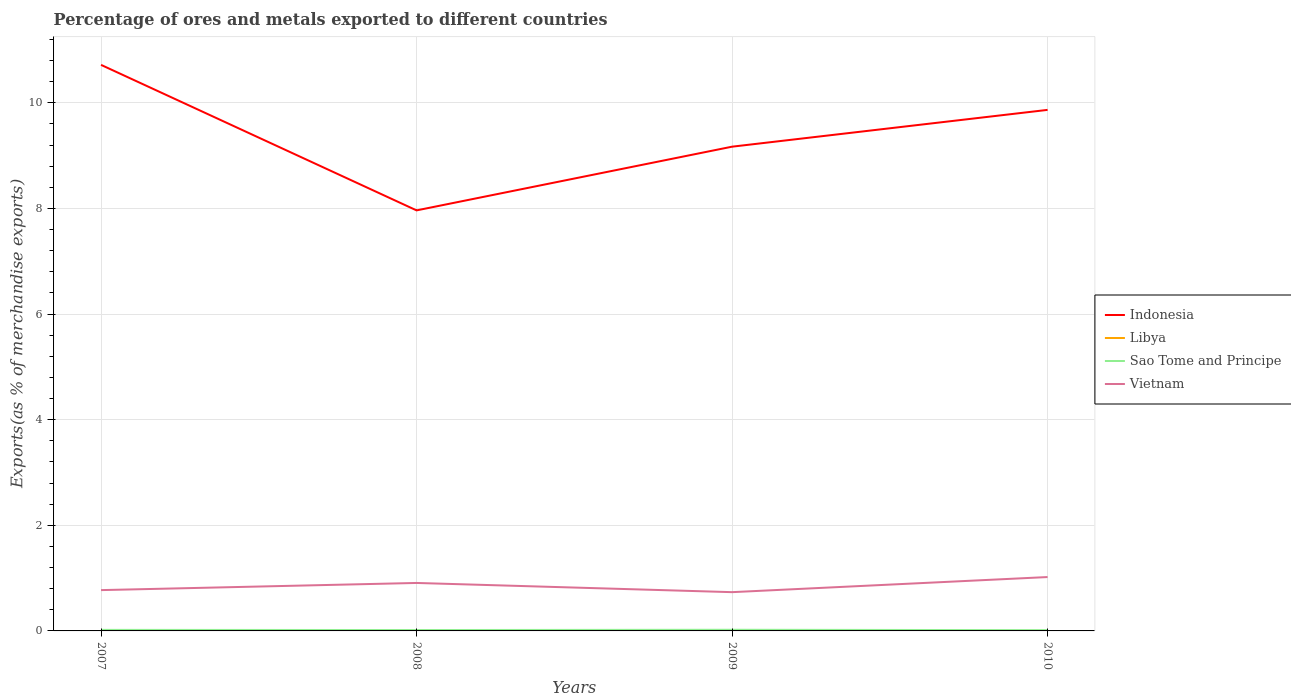How many different coloured lines are there?
Your response must be concise. 4. Is the number of lines equal to the number of legend labels?
Give a very brief answer. Yes. Across all years, what is the maximum percentage of exports to different countries in Libya?
Keep it short and to the point. 0. What is the total percentage of exports to different countries in Sao Tome and Principe in the graph?
Your answer should be compact. 0. What is the difference between the highest and the second highest percentage of exports to different countries in Sao Tome and Principe?
Your response must be concise. 0.01. Is the percentage of exports to different countries in Libya strictly greater than the percentage of exports to different countries in Vietnam over the years?
Provide a short and direct response. Yes. How many lines are there?
Give a very brief answer. 4. How many years are there in the graph?
Give a very brief answer. 4. What is the difference between two consecutive major ticks on the Y-axis?
Your answer should be very brief. 2. Are the values on the major ticks of Y-axis written in scientific E-notation?
Your answer should be compact. No. Does the graph contain grids?
Your answer should be very brief. Yes. How many legend labels are there?
Offer a very short reply. 4. What is the title of the graph?
Make the answer very short. Percentage of ores and metals exported to different countries. What is the label or title of the X-axis?
Provide a short and direct response. Years. What is the label or title of the Y-axis?
Give a very brief answer. Exports(as % of merchandise exports). What is the Exports(as % of merchandise exports) in Indonesia in 2007?
Offer a very short reply. 10.72. What is the Exports(as % of merchandise exports) of Libya in 2007?
Your response must be concise. 0.01. What is the Exports(as % of merchandise exports) in Sao Tome and Principe in 2007?
Your answer should be very brief. 0.02. What is the Exports(as % of merchandise exports) in Vietnam in 2007?
Keep it short and to the point. 0.77. What is the Exports(as % of merchandise exports) of Indonesia in 2008?
Give a very brief answer. 7.96. What is the Exports(as % of merchandise exports) in Libya in 2008?
Give a very brief answer. 0.01. What is the Exports(as % of merchandise exports) of Sao Tome and Principe in 2008?
Ensure brevity in your answer.  0.02. What is the Exports(as % of merchandise exports) in Vietnam in 2008?
Keep it short and to the point. 0.91. What is the Exports(as % of merchandise exports) in Indonesia in 2009?
Provide a short and direct response. 9.17. What is the Exports(as % of merchandise exports) in Libya in 2009?
Your response must be concise. 0. What is the Exports(as % of merchandise exports) in Sao Tome and Principe in 2009?
Provide a short and direct response. 0.02. What is the Exports(as % of merchandise exports) of Vietnam in 2009?
Your answer should be very brief. 0.73. What is the Exports(as % of merchandise exports) of Indonesia in 2010?
Give a very brief answer. 9.87. What is the Exports(as % of merchandise exports) in Libya in 2010?
Give a very brief answer. 0. What is the Exports(as % of merchandise exports) in Sao Tome and Principe in 2010?
Provide a short and direct response. 0.01. What is the Exports(as % of merchandise exports) in Vietnam in 2010?
Offer a very short reply. 1.02. Across all years, what is the maximum Exports(as % of merchandise exports) in Indonesia?
Your answer should be very brief. 10.72. Across all years, what is the maximum Exports(as % of merchandise exports) in Libya?
Give a very brief answer. 0.01. Across all years, what is the maximum Exports(as % of merchandise exports) in Sao Tome and Principe?
Provide a succinct answer. 0.02. Across all years, what is the maximum Exports(as % of merchandise exports) of Vietnam?
Your answer should be very brief. 1.02. Across all years, what is the minimum Exports(as % of merchandise exports) in Indonesia?
Provide a succinct answer. 7.96. Across all years, what is the minimum Exports(as % of merchandise exports) in Libya?
Ensure brevity in your answer.  0. Across all years, what is the minimum Exports(as % of merchandise exports) of Sao Tome and Principe?
Your answer should be compact. 0.01. Across all years, what is the minimum Exports(as % of merchandise exports) in Vietnam?
Your answer should be compact. 0.73. What is the total Exports(as % of merchandise exports) of Indonesia in the graph?
Provide a short and direct response. 37.72. What is the total Exports(as % of merchandise exports) of Libya in the graph?
Give a very brief answer. 0.01. What is the total Exports(as % of merchandise exports) in Sao Tome and Principe in the graph?
Your answer should be very brief. 0.07. What is the total Exports(as % of merchandise exports) in Vietnam in the graph?
Your answer should be compact. 3.44. What is the difference between the Exports(as % of merchandise exports) in Indonesia in 2007 and that in 2008?
Give a very brief answer. 2.76. What is the difference between the Exports(as % of merchandise exports) of Libya in 2007 and that in 2008?
Provide a short and direct response. 0. What is the difference between the Exports(as % of merchandise exports) in Sao Tome and Principe in 2007 and that in 2008?
Ensure brevity in your answer.  0. What is the difference between the Exports(as % of merchandise exports) of Vietnam in 2007 and that in 2008?
Provide a succinct answer. -0.14. What is the difference between the Exports(as % of merchandise exports) of Indonesia in 2007 and that in 2009?
Offer a terse response. 1.55. What is the difference between the Exports(as % of merchandise exports) of Libya in 2007 and that in 2009?
Keep it short and to the point. 0.01. What is the difference between the Exports(as % of merchandise exports) in Sao Tome and Principe in 2007 and that in 2009?
Provide a short and direct response. -0. What is the difference between the Exports(as % of merchandise exports) of Vietnam in 2007 and that in 2009?
Give a very brief answer. 0.04. What is the difference between the Exports(as % of merchandise exports) of Indonesia in 2007 and that in 2010?
Ensure brevity in your answer.  0.85. What is the difference between the Exports(as % of merchandise exports) of Libya in 2007 and that in 2010?
Offer a very short reply. 0.01. What is the difference between the Exports(as % of merchandise exports) of Sao Tome and Principe in 2007 and that in 2010?
Provide a short and direct response. 0.01. What is the difference between the Exports(as % of merchandise exports) in Vietnam in 2007 and that in 2010?
Your answer should be very brief. -0.25. What is the difference between the Exports(as % of merchandise exports) of Indonesia in 2008 and that in 2009?
Ensure brevity in your answer.  -1.21. What is the difference between the Exports(as % of merchandise exports) of Libya in 2008 and that in 2009?
Provide a succinct answer. 0.01. What is the difference between the Exports(as % of merchandise exports) in Sao Tome and Principe in 2008 and that in 2009?
Keep it short and to the point. -0. What is the difference between the Exports(as % of merchandise exports) in Vietnam in 2008 and that in 2009?
Ensure brevity in your answer.  0.17. What is the difference between the Exports(as % of merchandise exports) in Indonesia in 2008 and that in 2010?
Your answer should be compact. -1.9. What is the difference between the Exports(as % of merchandise exports) of Libya in 2008 and that in 2010?
Give a very brief answer. 0.01. What is the difference between the Exports(as % of merchandise exports) of Sao Tome and Principe in 2008 and that in 2010?
Offer a very short reply. 0. What is the difference between the Exports(as % of merchandise exports) in Vietnam in 2008 and that in 2010?
Your answer should be compact. -0.11. What is the difference between the Exports(as % of merchandise exports) of Indonesia in 2009 and that in 2010?
Keep it short and to the point. -0.7. What is the difference between the Exports(as % of merchandise exports) in Libya in 2009 and that in 2010?
Offer a terse response. -0. What is the difference between the Exports(as % of merchandise exports) in Sao Tome and Principe in 2009 and that in 2010?
Provide a short and direct response. 0.01. What is the difference between the Exports(as % of merchandise exports) in Vietnam in 2009 and that in 2010?
Your answer should be very brief. -0.29. What is the difference between the Exports(as % of merchandise exports) in Indonesia in 2007 and the Exports(as % of merchandise exports) in Libya in 2008?
Give a very brief answer. 10.71. What is the difference between the Exports(as % of merchandise exports) of Indonesia in 2007 and the Exports(as % of merchandise exports) of Sao Tome and Principe in 2008?
Your answer should be very brief. 10.7. What is the difference between the Exports(as % of merchandise exports) of Indonesia in 2007 and the Exports(as % of merchandise exports) of Vietnam in 2008?
Your answer should be very brief. 9.81. What is the difference between the Exports(as % of merchandise exports) of Libya in 2007 and the Exports(as % of merchandise exports) of Sao Tome and Principe in 2008?
Offer a terse response. -0.01. What is the difference between the Exports(as % of merchandise exports) in Libya in 2007 and the Exports(as % of merchandise exports) in Vietnam in 2008?
Offer a very short reply. -0.9. What is the difference between the Exports(as % of merchandise exports) in Sao Tome and Principe in 2007 and the Exports(as % of merchandise exports) in Vietnam in 2008?
Offer a terse response. -0.89. What is the difference between the Exports(as % of merchandise exports) of Indonesia in 2007 and the Exports(as % of merchandise exports) of Libya in 2009?
Offer a very short reply. 10.72. What is the difference between the Exports(as % of merchandise exports) in Indonesia in 2007 and the Exports(as % of merchandise exports) in Sao Tome and Principe in 2009?
Provide a succinct answer. 10.7. What is the difference between the Exports(as % of merchandise exports) of Indonesia in 2007 and the Exports(as % of merchandise exports) of Vietnam in 2009?
Offer a terse response. 9.98. What is the difference between the Exports(as % of merchandise exports) of Libya in 2007 and the Exports(as % of merchandise exports) of Sao Tome and Principe in 2009?
Make the answer very short. -0.01. What is the difference between the Exports(as % of merchandise exports) of Libya in 2007 and the Exports(as % of merchandise exports) of Vietnam in 2009?
Provide a succinct answer. -0.73. What is the difference between the Exports(as % of merchandise exports) of Sao Tome and Principe in 2007 and the Exports(as % of merchandise exports) of Vietnam in 2009?
Your response must be concise. -0.71. What is the difference between the Exports(as % of merchandise exports) of Indonesia in 2007 and the Exports(as % of merchandise exports) of Libya in 2010?
Provide a short and direct response. 10.72. What is the difference between the Exports(as % of merchandise exports) of Indonesia in 2007 and the Exports(as % of merchandise exports) of Sao Tome and Principe in 2010?
Give a very brief answer. 10.7. What is the difference between the Exports(as % of merchandise exports) of Indonesia in 2007 and the Exports(as % of merchandise exports) of Vietnam in 2010?
Give a very brief answer. 9.7. What is the difference between the Exports(as % of merchandise exports) of Libya in 2007 and the Exports(as % of merchandise exports) of Sao Tome and Principe in 2010?
Give a very brief answer. -0.01. What is the difference between the Exports(as % of merchandise exports) of Libya in 2007 and the Exports(as % of merchandise exports) of Vietnam in 2010?
Make the answer very short. -1.01. What is the difference between the Exports(as % of merchandise exports) in Sao Tome and Principe in 2007 and the Exports(as % of merchandise exports) in Vietnam in 2010?
Your response must be concise. -1. What is the difference between the Exports(as % of merchandise exports) in Indonesia in 2008 and the Exports(as % of merchandise exports) in Libya in 2009?
Ensure brevity in your answer.  7.96. What is the difference between the Exports(as % of merchandise exports) in Indonesia in 2008 and the Exports(as % of merchandise exports) in Sao Tome and Principe in 2009?
Give a very brief answer. 7.94. What is the difference between the Exports(as % of merchandise exports) in Indonesia in 2008 and the Exports(as % of merchandise exports) in Vietnam in 2009?
Make the answer very short. 7.23. What is the difference between the Exports(as % of merchandise exports) of Libya in 2008 and the Exports(as % of merchandise exports) of Sao Tome and Principe in 2009?
Offer a very short reply. -0.01. What is the difference between the Exports(as % of merchandise exports) in Libya in 2008 and the Exports(as % of merchandise exports) in Vietnam in 2009?
Make the answer very short. -0.73. What is the difference between the Exports(as % of merchandise exports) of Sao Tome and Principe in 2008 and the Exports(as % of merchandise exports) of Vietnam in 2009?
Your answer should be compact. -0.72. What is the difference between the Exports(as % of merchandise exports) of Indonesia in 2008 and the Exports(as % of merchandise exports) of Libya in 2010?
Ensure brevity in your answer.  7.96. What is the difference between the Exports(as % of merchandise exports) of Indonesia in 2008 and the Exports(as % of merchandise exports) of Sao Tome and Principe in 2010?
Your response must be concise. 7.95. What is the difference between the Exports(as % of merchandise exports) in Indonesia in 2008 and the Exports(as % of merchandise exports) in Vietnam in 2010?
Keep it short and to the point. 6.94. What is the difference between the Exports(as % of merchandise exports) of Libya in 2008 and the Exports(as % of merchandise exports) of Sao Tome and Principe in 2010?
Your answer should be very brief. -0.01. What is the difference between the Exports(as % of merchandise exports) in Libya in 2008 and the Exports(as % of merchandise exports) in Vietnam in 2010?
Your answer should be very brief. -1.01. What is the difference between the Exports(as % of merchandise exports) in Sao Tome and Principe in 2008 and the Exports(as % of merchandise exports) in Vietnam in 2010?
Offer a terse response. -1. What is the difference between the Exports(as % of merchandise exports) in Indonesia in 2009 and the Exports(as % of merchandise exports) in Libya in 2010?
Your response must be concise. 9.17. What is the difference between the Exports(as % of merchandise exports) of Indonesia in 2009 and the Exports(as % of merchandise exports) of Sao Tome and Principe in 2010?
Your answer should be compact. 9.16. What is the difference between the Exports(as % of merchandise exports) of Indonesia in 2009 and the Exports(as % of merchandise exports) of Vietnam in 2010?
Your answer should be very brief. 8.15. What is the difference between the Exports(as % of merchandise exports) in Libya in 2009 and the Exports(as % of merchandise exports) in Sao Tome and Principe in 2010?
Ensure brevity in your answer.  -0.01. What is the difference between the Exports(as % of merchandise exports) of Libya in 2009 and the Exports(as % of merchandise exports) of Vietnam in 2010?
Make the answer very short. -1.02. What is the difference between the Exports(as % of merchandise exports) in Sao Tome and Principe in 2009 and the Exports(as % of merchandise exports) in Vietnam in 2010?
Your answer should be very brief. -1. What is the average Exports(as % of merchandise exports) in Indonesia per year?
Give a very brief answer. 9.43. What is the average Exports(as % of merchandise exports) in Libya per year?
Your response must be concise. 0. What is the average Exports(as % of merchandise exports) in Sao Tome and Principe per year?
Your response must be concise. 0.02. What is the average Exports(as % of merchandise exports) of Vietnam per year?
Give a very brief answer. 0.86. In the year 2007, what is the difference between the Exports(as % of merchandise exports) of Indonesia and Exports(as % of merchandise exports) of Libya?
Provide a succinct answer. 10.71. In the year 2007, what is the difference between the Exports(as % of merchandise exports) of Indonesia and Exports(as % of merchandise exports) of Sao Tome and Principe?
Provide a succinct answer. 10.7. In the year 2007, what is the difference between the Exports(as % of merchandise exports) in Indonesia and Exports(as % of merchandise exports) in Vietnam?
Offer a terse response. 9.95. In the year 2007, what is the difference between the Exports(as % of merchandise exports) of Libya and Exports(as % of merchandise exports) of Sao Tome and Principe?
Ensure brevity in your answer.  -0.01. In the year 2007, what is the difference between the Exports(as % of merchandise exports) in Libya and Exports(as % of merchandise exports) in Vietnam?
Your response must be concise. -0.77. In the year 2007, what is the difference between the Exports(as % of merchandise exports) in Sao Tome and Principe and Exports(as % of merchandise exports) in Vietnam?
Keep it short and to the point. -0.75. In the year 2008, what is the difference between the Exports(as % of merchandise exports) in Indonesia and Exports(as % of merchandise exports) in Libya?
Keep it short and to the point. 7.96. In the year 2008, what is the difference between the Exports(as % of merchandise exports) in Indonesia and Exports(as % of merchandise exports) in Sao Tome and Principe?
Make the answer very short. 7.95. In the year 2008, what is the difference between the Exports(as % of merchandise exports) of Indonesia and Exports(as % of merchandise exports) of Vietnam?
Offer a very short reply. 7.05. In the year 2008, what is the difference between the Exports(as % of merchandise exports) in Libya and Exports(as % of merchandise exports) in Sao Tome and Principe?
Your answer should be very brief. -0.01. In the year 2008, what is the difference between the Exports(as % of merchandise exports) of Libya and Exports(as % of merchandise exports) of Vietnam?
Keep it short and to the point. -0.9. In the year 2008, what is the difference between the Exports(as % of merchandise exports) of Sao Tome and Principe and Exports(as % of merchandise exports) of Vietnam?
Offer a terse response. -0.89. In the year 2009, what is the difference between the Exports(as % of merchandise exports) of Indonesia and Exports(as % of merchandise exports) of Libya?
Provide a succinct answer. 9.17. In the year 2009, what is the difference between the Exports(as % of merchandise exports) in Indonesia and Exports(as % of merchandise exports) in Sao Tome and Principe?
Your answer should be compact. 9.15. In the year 2009, what is the difference between the Exports(as % of merchandise exports) in Indonesia and Exports(as % of merchandise exports) in Vietnam?
Offer a terse response. 8.44. In the year 2009, what is the difference between the Exports(as % of merchandise exports) in Libya and Exports(as % of merchandise exports) in Sao Tome and Principe?
Your answer should be very brief. -0.02. In the year 2009, what is the difference between the Exports(as % of merchandise exports) in Libya and Exports(as % of merchandise exports) in Vietnam?
Offer a very short reply. -0.73. In the year 2009, what is the difference between the Exports(as % of merchandise exports) of Sao Tome and Principe and Exports(as % of merchandise exports) of Vietnam?
Offer a terse response. -0.71. In the year 2010, what is the difference between the Exports(as % of merchandise exports) of Indonesia and Exports(as % of merchandise exports) of Libya?
Keep it short and to the point. 9.87. In the year 2010, what is the difference between the Exports(as % of merchandise exports) of Indonesia and Exports(as % of merchandise exports) of Sao Tome and Principe?
Offer a very short reply. 9.85. In the year 2010, what is the difference between the Exports(as % of merchandise exports) in Indonesia and Exports(as % of merchandise exports) in Vietnam?
Your answer should be compact. 8.85. In the year 2010, what is the difference between the Exports(as % of merchandise exports) of Libya and Exports(as % of merchandise exports) of Sao Tome and Principe?
Make the answer very short. -0.01. In the year 2010, what is the difference between the Exports(as % of merchandise exports) of Libya and Exports(as % of merchandise exports) of Vietnam?
Provide a succinct answer. -1.02. In the year 2010, what is the difference between the Exports(as % of merchandise exports) in Sao Tome and Principe and Exports(as % of merchandise exports) in Vietnam?
Keep it short and to the point. -1.01. What is the ratio of the Exports(as % of merchandise exports) in Indonesia in 2007 to that in 2008?
Provide a succinct answer. 1.35. What is the ratio of the Exports(as % of merchandise exports) in Sao Tome and Principe in 2007 to that in 2008?
Your response must be concise. 1.18. What is the ratio of the Exports(as % of merchandise exports) of Vietnam in 2007 to that in 2008?
Offer a terse response. 0.85. What is the ratio of the Exports(as % of merchandise exports) in Indonesia in 2007 to that in 2009?
Provide a succinct answer. 1.17. What is the ratio of the Exports(as % of merchandise exports) of Libya in 2007 to that in 2009?
Offer a very short reply. 45.64. What is the ratio of the Exports(as % of merchandise exports) of Sao Tome and Principe in 2007 to that in 2009?
Your response must be concise. 0.91. What is the ratio of the Exports(as % of merchandise exports) of Vietnam in 2007 to that in 2009?
Ensure brevity in your answer.  1.05. What is the ratio of the Exports(as % of merchandise exports) in Indonesia in 2007 to that in 2010?
Offer a terse response. 1.09. What is the ratio of the Exports(as % of merchandise exports) in Libya in 2007 to that in 2010?
Your answer should be very brief. 18.36. What is the ratio of the Exports(as % of merchandise exports) in Sao Tome and Principe in 2007 to that in 2010?
Your answer should be very brief. 1.36. What is the ratio of the Exports(as % of merchandise exports) of Vietnam in 2007 to that in 2010?
Offer a very short reply. 0.76. What is the ratio of the Exports(as % of merchandise exports) of Indonesia in 2008 to that in 2009?
Your response must be concise. 0.87. What is the ratio of the Exports(as % of merchandise exports) in Libya in 2008 to that in 2009?
Offer a very short reply. 45.52. What is the ratio of the Exports(as % of merchandise exports) of Sao Tome and Principe in 2008 to that in 2009?
Ensure brevity in your answer.  0.78. What is the ratio of the Exports(as % of merchandise exports) in Vietnam in 2008 to that in 2009?
Provide a succinct answer. 1.24. What is the ratio of the Exports(as % of merchandise exports) in Indonesia in 2008 to that in 2010?
Provide a succinct answer. 0.81. What is the ratio of the Exports(as % of merchandise exports) of Libya in 2008 to that in 2010?
Offer a very short reply. 18.31. What is the ratio of the Exports(as % of merchandise exports) in Sao Tome and Principe in 2008 to that in 2010?
Provide a short and direct response. 1.15. What is the ratio of the Exports(as % of merchandise exports) of Vietnam in 2008 to that in 2010?
Offer a terse response. 0.89. What is the ratio of the Exports(as % of merchandise exports) in Indonesia in 2009 to that in 2010?
Offer a terse response. 0.93. What is the ratio of the Exports(as % of merchandise exports) of Libya in 2009 to that in 2010?
Give a very brief answer. 0.4. What is the ratio of the Exports(as % of merchandise exports) in Sao Tome and Principe in 2009 to that in 2010?
Ensure brevity in your answer.  1.49. What is the ratio of the Exports(as % of merchandise exports) in Vietnam in 2009 to that in 2010?
Ensure brevity in your answer.  0.72. What is the difference between the highest and the second highest Exports(as % of merchandise exports) of Indonesia?
Offer a very short reply. 0.85. What is the difference between the highest and the second highest Exports(as % of merchandise exports) in Sao Tome and Principe?
Make the answer very short. 0. What is the difference between the highest and the second highest Exports(as % of merchandise exports) in Vietnam?
Your response must be concise. 0.11. What is the difference between the highest and the lowest Exports(as % of merchandise exports) in Indonesia?
Offer a very short reply. 2.76. What is the difference between the highest and the lowest Exports(as % of merchandise exports) in Libya?
Give a very brief answer. 0.01. What is the difference between the highest and the lowest Exports(as % of merchandise exports) of Sao Tome and Principe?
Your answer should be compact. 0.01. What is the difference between the highest and the lowest Exports(as % of merchandise exports) of Vietnam?
Keep it short and to the point. 0.29. 